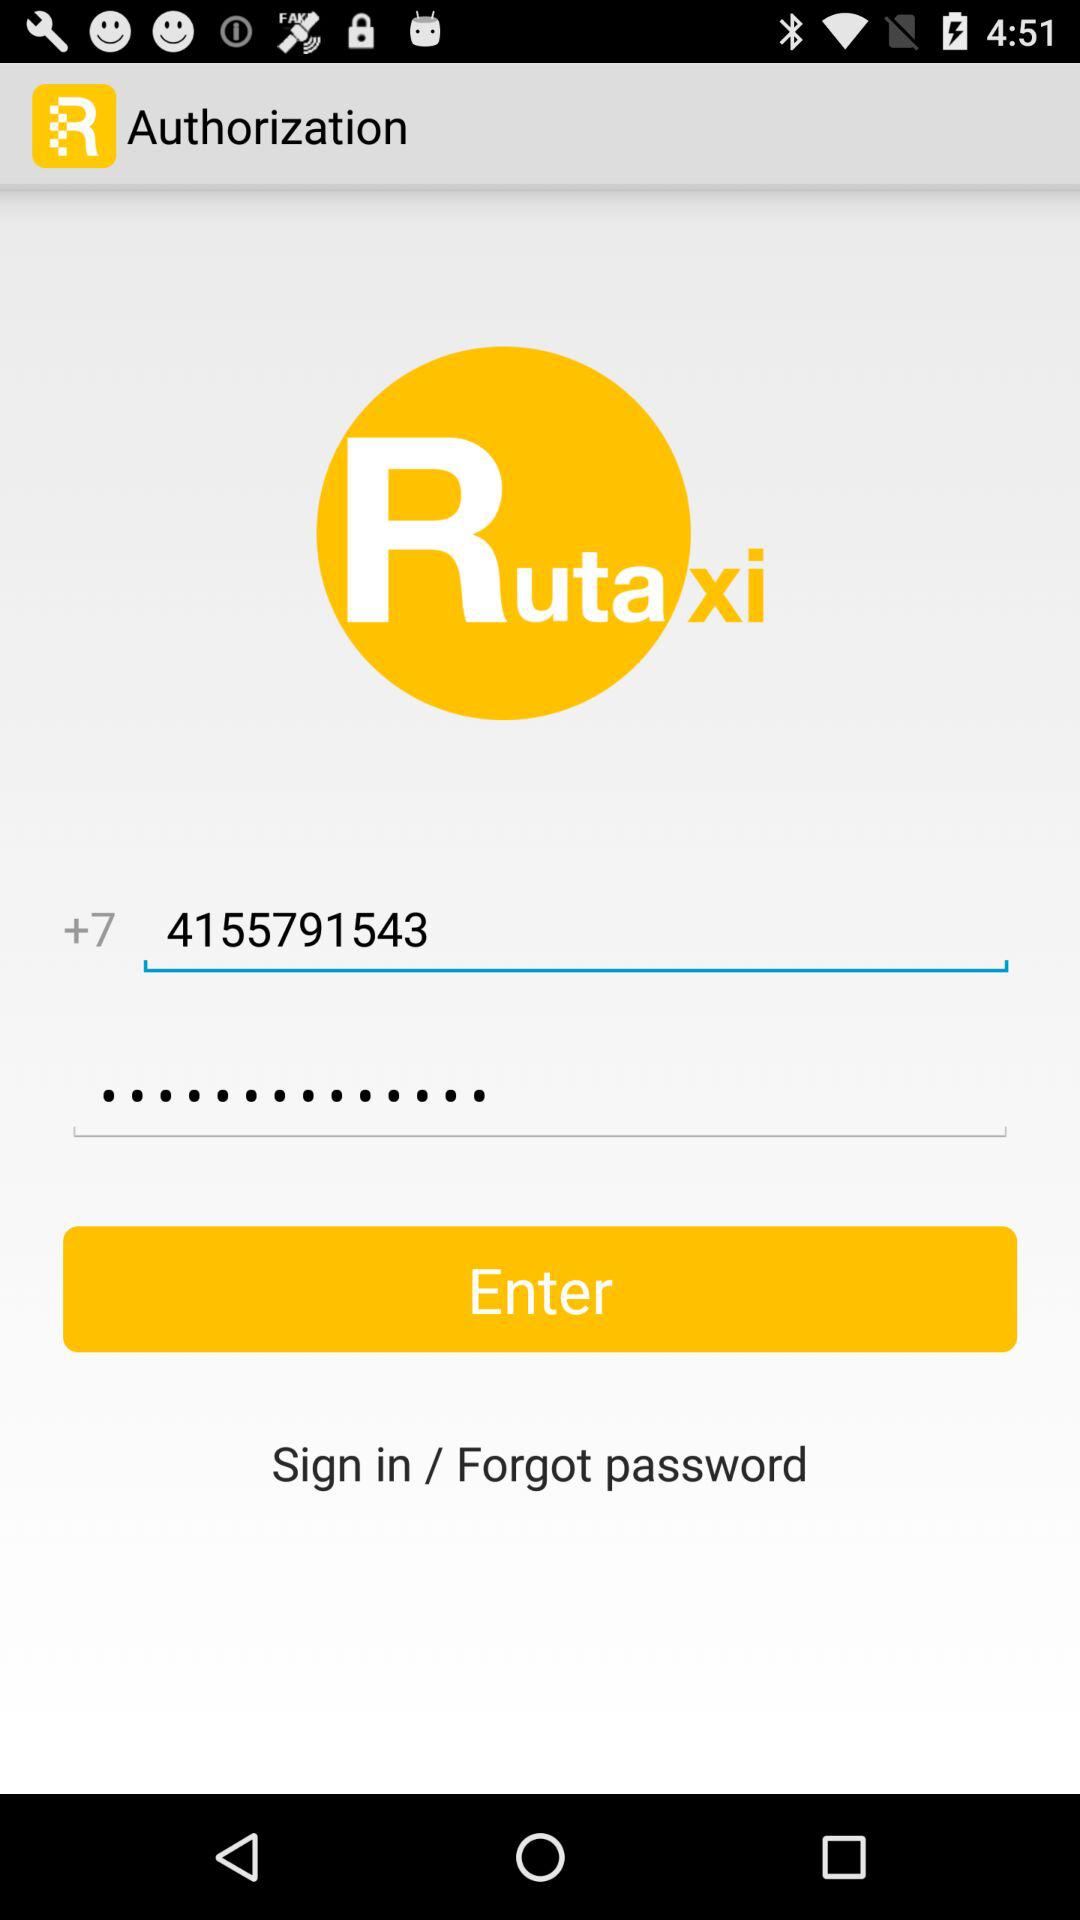What is the application name? The application name is "Rutaxi". 